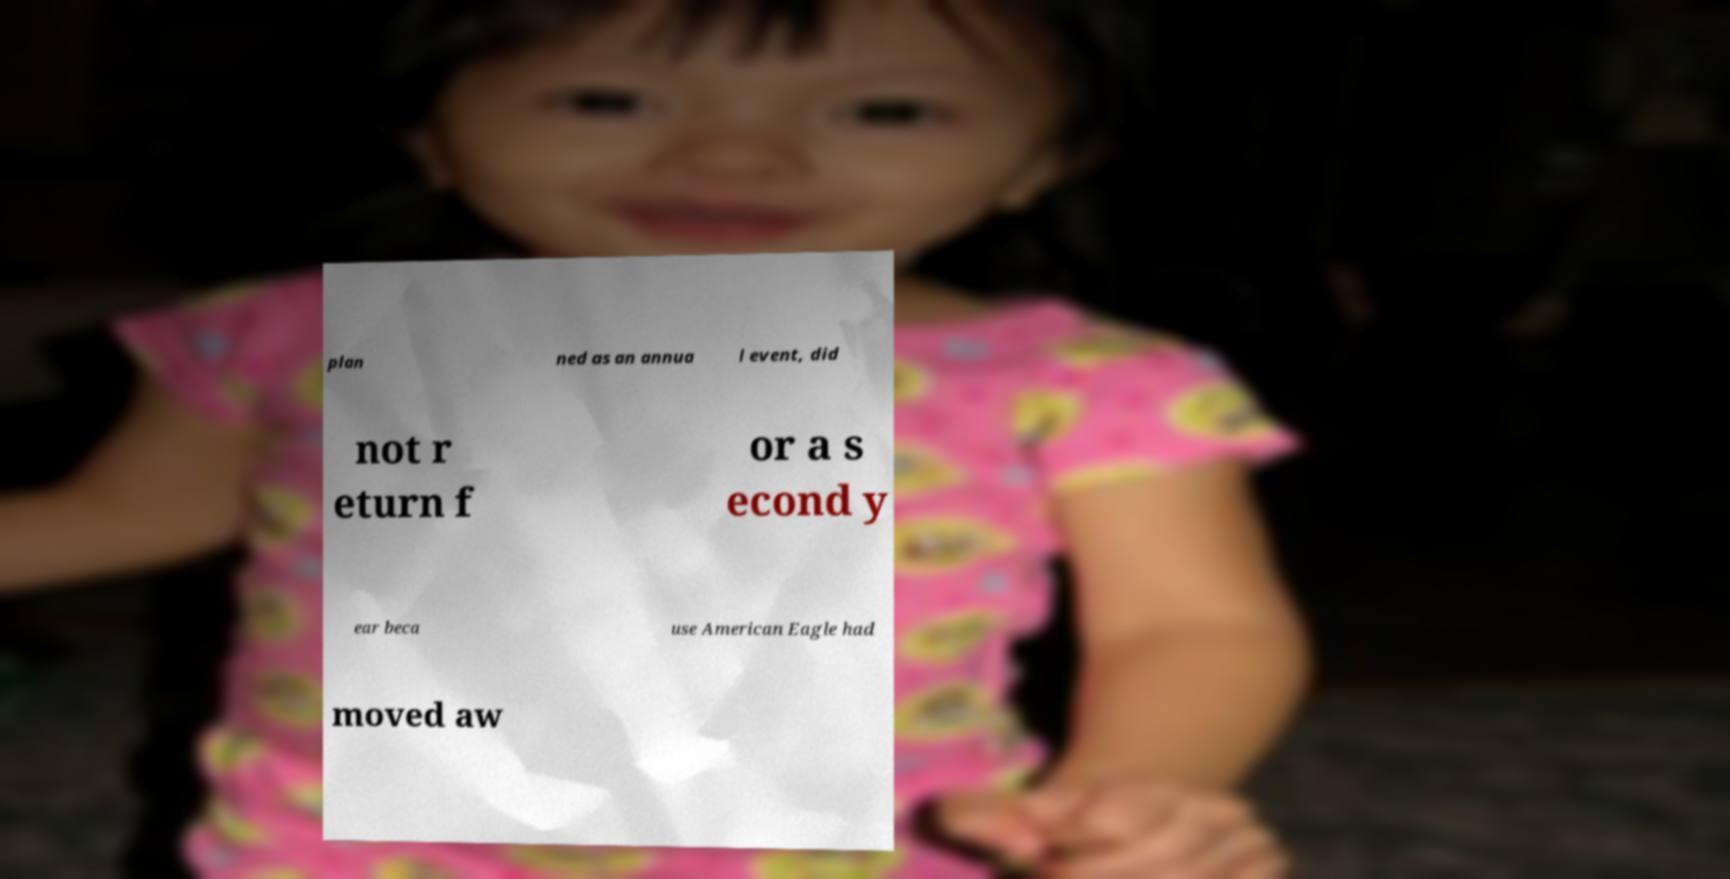Can you accurately transcribe the text from the provided image for me? plan ned as an annua l event, did not r eturn f or a s econd y ear beca use American Eagle had moved aw 